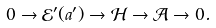Convert formula to latex. <formula><loc_0><loc_0><loc_500><loc_500>0 \rightarrow { \mathcal { E } } ^ { \prime } ( a ^ { \prime } ) \rightarrow { \mathcal { H } } \rightarrow { \mathcal { A } } \rightarrow 0 .</formula> 